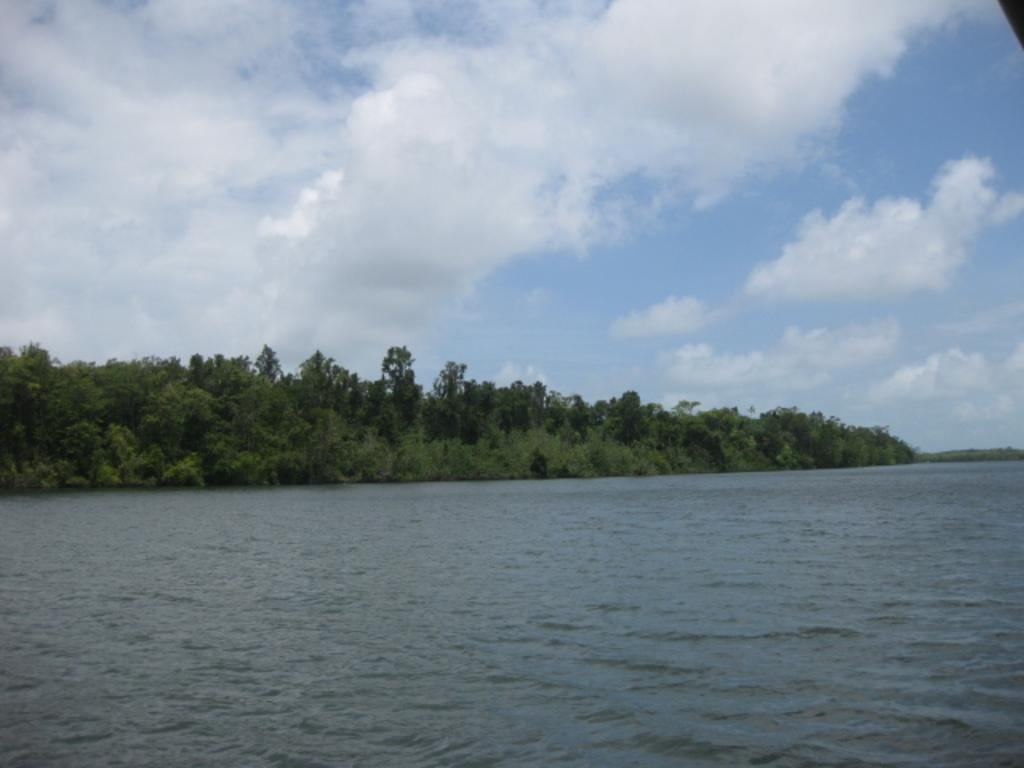What type of natural feature is located at the bottom of the image? There is a river at the bottom of the image. What can be seen in the center of the image? There are trees in the center of the image. What is visible at the top of the image? The sky is visible at the top of the image. What type of steel apparatus is present in the image? There is no steel apparatus present in the image. What key is used to unlock the door in the image? There is no door or key present in the image. 